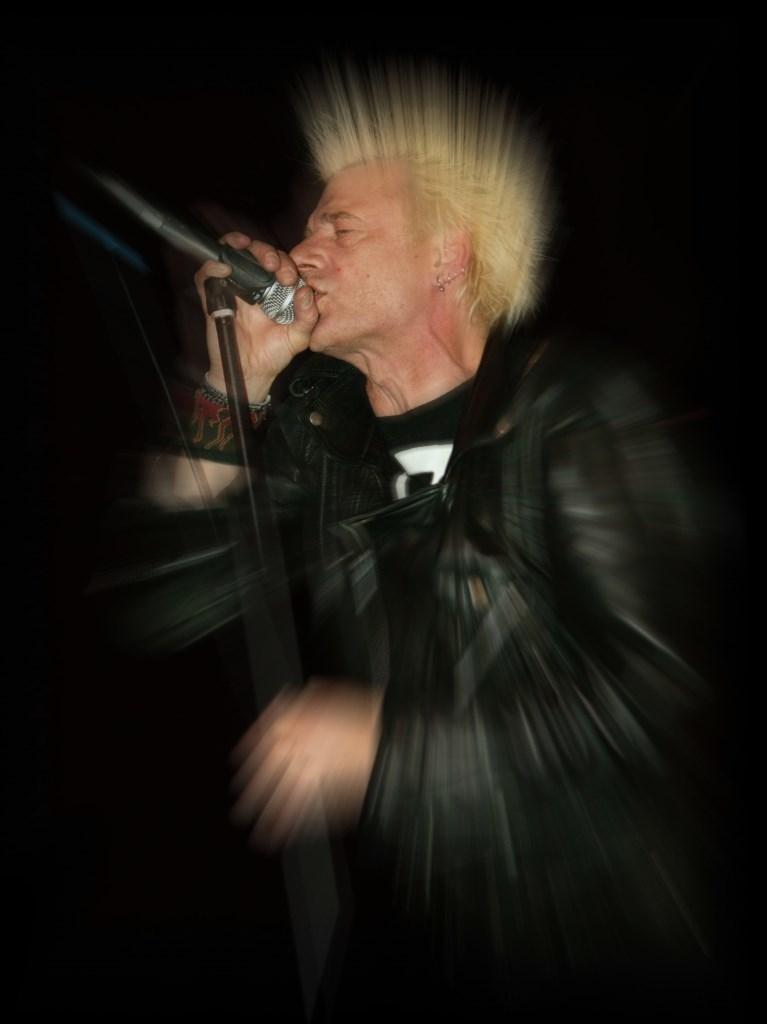Who is the main subject in the image? There is a man in the image. What is the man wearing? The man is wearing a black jacket. What is the man holding in the image? The man is holding a mic. Can you describe the quality of the image? The image is blurred. What type of list is the man holding in the image? The man is not holding a list in the image; he is holding a mic. What color is the spy's hat in the image? There is no spy or hat present in the image. 